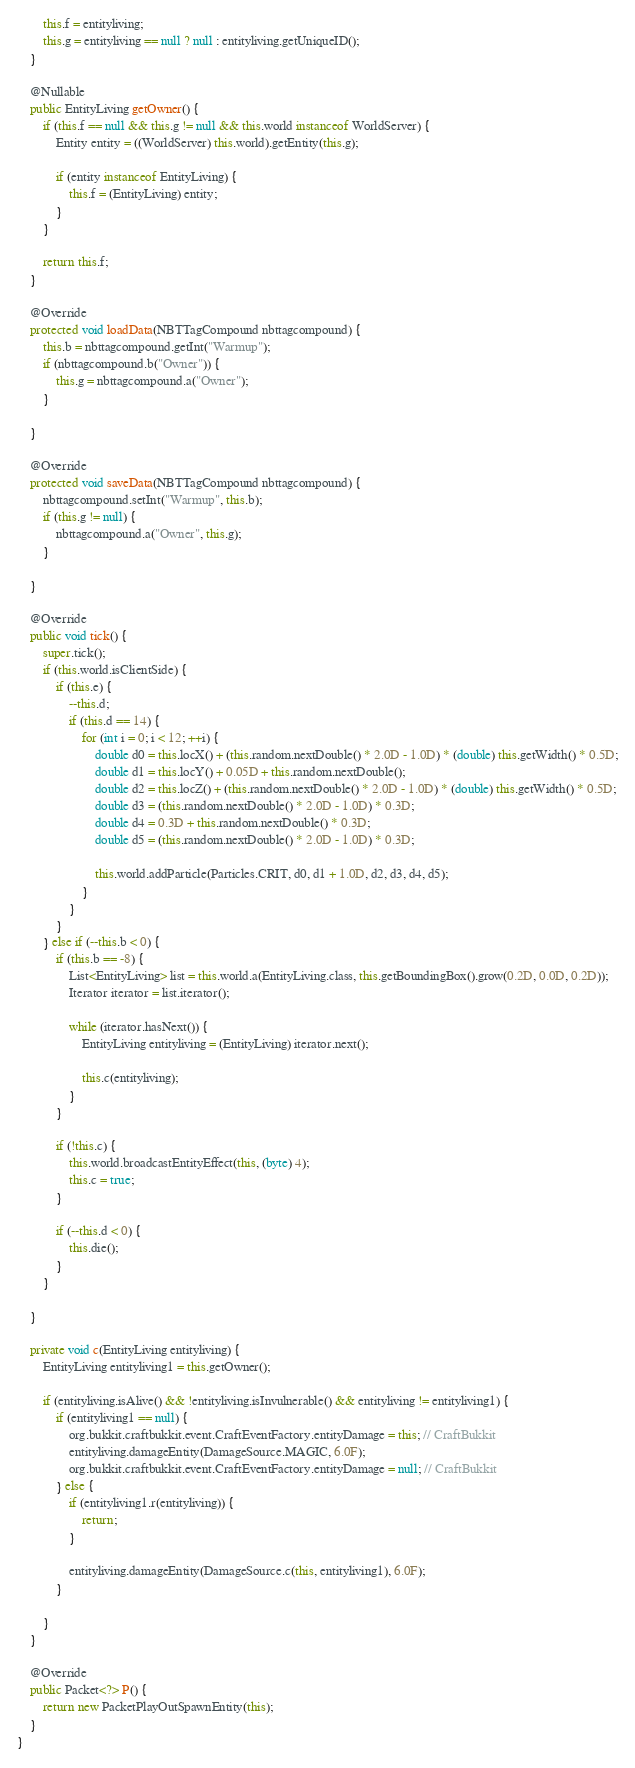<code> <loc_0><loc_0><loc_500><loc_500><_Java_>        this.f = entityliving;
        this.g = entityliving == null ? null : entityliving.getUniqueID();
    }

    @Nullable
    public EntityLiving getOwner() {
        if (this.f == null && this.g != null && this.world instanceof WorldServer) {
            Entity entity = ((WorldServer) this.world).getEntity(this.g);

            if (entity instanceof EntityLiving) {
                this.f = (EntityLiving) entity;
            }
        }

        return this.f;
    }

    @Override
    protected void loadData(NBTTagCompound nbttagcompound) {
        this.b = nbttagcompound.getInt("Warmup");
        if (nbttagcompound.b("Owner")) {
            this.g = nbttagcompound.a("Owner");
        }

    }

    @Override
    protected void saveData(NBTTagCompound nbttagcompound) {
        nbttagcompound.setInt("Warmup", this.b);
        if (this.g != null) {
            nbttagcompound.a("Owner", this.g);
        }

    }

    @Override
    public void tick() {
        super.tick();
        if (this.world.isClientSide) {
            if (this.e) {
                --this.d;
                if (this.d == 14) {
                    for (int i = 0; i < 12; ++i) {
                        double d0 = this.locX() + (this.random.nextDouble() * 2.0D - 1.0D) * (double) this.getWidth() * 0.5D;
                        double d1 = this.locY() + 0.05D + this.random.nextDouble();
                        double d2 = this.locZ() + (this.random.nextDouble() * 2.0D - 1.0D) * (double) this.getWidth() * 0.5D;
                        double d3 = (this.random.nextDouble() * 2.0D - 1.0D) * 0.3D;
                        double d4 = 0.3D + this.random.nextDouble() * 0.3D;
                        double d5 = (this.random.nextDouble() * 2.0D - 1.0D) * 0.3D;

                        this.world.addParticle(Particles.CRIT, d0, d1 + 1.0D, d2, d3, d4, d5);
                    }
                }
            }
        } else if (--this.b < 0) {
            if (this.b == -8) {
                List<EntityLiving> list = this.world.a(EntityLiving.class, this.getBoundingBox().grow(0.2D, 0.0D, 0.2D));
                Iterator iterator = list.iterator();

                while (iterator.hasNext()) {
                    EntityLiving entityliving = (EntityLiving) iterator.next();

                    this.c(entityliving);
                }
            }

            if (!this.c) {
                this.world.broadcastEntityEffect(this, (byte) 4);
                this.c = true;
            }

            if (--this.d < 0) {
                this.die();
            }
        }

    }

    private void c(EntityLiving entityliving) {
        EntityLiving entityliving1 = this.getOwner();

        if (entityliving.isAlive() && !entityliving.isInvulnerable() && entityliving != entityliving1) {
            if (entityliving1 == null) {
                org.bukkit.craftbukkit.event.CraftEventFactory.entityDamage = this; // CraftBukkit
                entityliving.damageEntity(DamageSource.MAGIC, 6.0F);
                org.bukkit.craftbukkit.event.CraftEventFactory.entityDamage = null; // CraftBukkit
            } else {
                if (entityliving1.r(entityliving)) {
                    return;
                }

                entityliving.damageEntity(DamageSource.c(this, entityliving1), 6.0F);
            }

        }
    }

    @Override
    public Packet<?> P() {
        return new PacketPlayOutSpawnEntity(this);
    }
}
</code> 